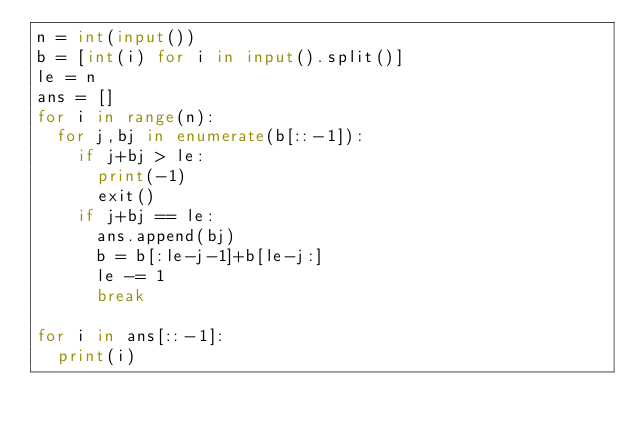Convert code to text. <code><loc_0><loc_0><loc_500><loc_500><_Python_>n = int(input())
b = [int(i) for i in input().split()]
le = n
ans = []
for i in range(n):
  for j,bj in enumerate(b[::-1]):
    if j+bj > le:
      print(-1)
      exit()
    if j+bj == le:
      ans.append(bj)
      b = b[:le-j-1]+b[le-j:]
      le -= 1
      break
      
for i in ans[::-1]:
  print(i)</code> 